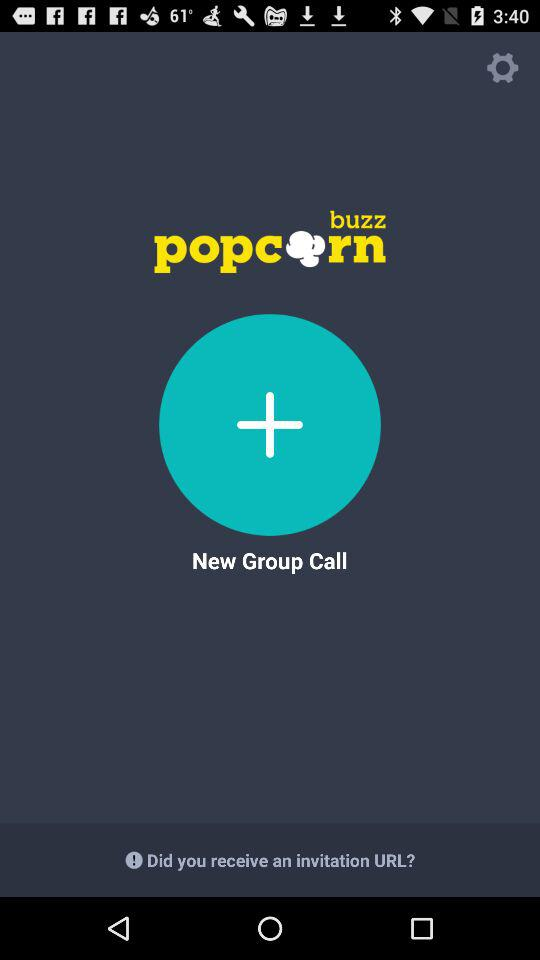When was the invitation URL received?
When the provided information is insufficient, respond with <no answer>. <no answer> 